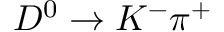<formula> <loc_0><loc_0><loc_500><loc_500>D ^ { 0 } \to K ^ { - } \pi ^ { + }</formula> 